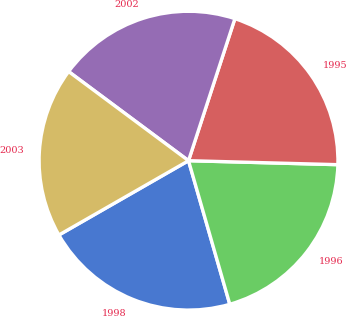<chart> <loc_0><loc_0><loc_500><loc_500><pie_chart><fcel>1998<fcel>1996<fcel>1995<fcel>2002<fcel>2003<nl><fcel>21.17%<fcel>20.12%<fcel>20.4%<fcel>19.85%<fcel>18.46%<nl></chart> 